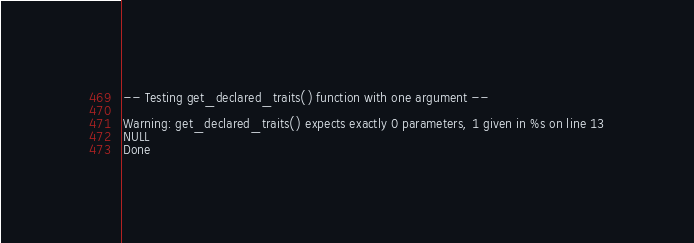Convert code to text. <code><loc_0><loc_0><loc_500><loc_500><_PHP_>
-- Testing get_declared_traits() function with one argument --

Warning: get_declared_traits() expects exactly 0 parameters, 1 given in %s on line 13
NULL
Done
</code> 